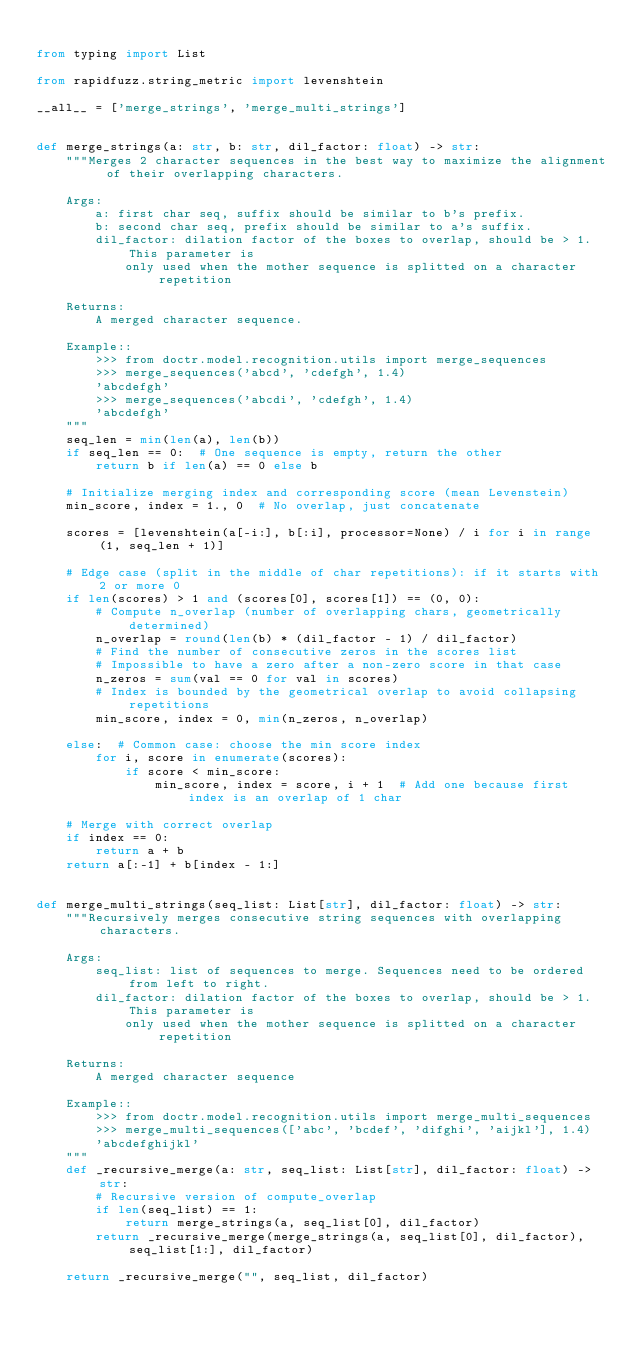<code> <loc_0><loc_0><loc_500><loc_500><_Python_>
from typing import List

from rapidfuzz.string_metric import levenshtein

__all__ = ['merge_strings', 'merge_multi_strings']


def merge_strings(a: str, b: str, dil_factor: float) -> str:
    """Merges 2 character sequences in the best way to maximize the alignment of their overlapping characters.

    Args:
        a: first char seq, suffix should be similar to b's prefix.
        b: second char seq, prefix should be similar to a's suffix.
        dil_factor: dilation factor of the boxes to overlap, should be > 1. This parameter is
            only used when the mother sequence is splitted on a character repetition

    Returns:
        A merged character sequence.

    Example::
        >>> from doctr.model.recognition.utils import merge_sequences
        >>> merge_sequences('abcd', 'cdefgh', 1.4)
        'abcdefgh'
        >>> merge_sequences('abcdi', 'cdefgh', 1.4)
        'abcdefgh'
    """
    seq_len = min(len(a), len(b))
    if seq_len == 0:  # One sequence is empty, return the other
        return b if len(a) == 0 else b

    # Initialize merging index and corresponding score (mean Levenstein)
    min_score, index = 1., 0  # No overlap, just concatenate

    scores = [levenshtein(a[-i:], b[:i], processor=None) / i for i in range(1, seq_len + 1)]

    # Edge case (split in the middle of char repetitions): if it starts with 2 or more 0
    if len(scores) > 1 and (scores[0], scores[1]) == (0, 0):
        # Compute n_overlap (number of overlapping chars, geometrically determined)
        n_overlap = round(len(b) * (dil_factor - 1) / dil_factor)
        # Find the number of consecutive zeros in the scores list
        # Impossible to have a zero after a non-zero score in that case
        n_zeros = sum(val == 0 for val in scores)
        # Index is bounded by the geometrical overlap to avoid collapsing repetitions
        min_score, index = 0, min(n_zeros, n_overlap)

    else:  # Common case: choose the min score index
        for i, score in enumerate(scores):
            if score < min_score:
                min_score, index = score, i + 1  # Add one because first index is an overlap of 1 char

    # Merge with correct overlap
    if index == 0:
        return a + b
    return a[:-1] + b[index - 1:]


def merge_multi_strings(seq_list: List[str], dil_factor: float) -> str:
    """Recursively merges consecutive string sequences with overlapping characters.

    Args:
        seq_list: list of sequences to merge. Sequences need to be ordered from left to right.
        dil_factor: dilation factor of the boxes to overlap, should be > 1. This parameter is
            only used when the mother sequence is splitted on a character repetition

    Returns:
        A merged character sequence

    Example::
        >>> from doctr.model.recognition.utils import merge_multi_sequences
        >>> merge_multi_sequences(['abc', 'bcdef', 'difghi', 'aijkl'], 1.4)
        'abcdefghijkl'
    """
    def _recursive_merge(a: str, seq_list: List[str], dil_factor: float) -> str:
        # Recursive version of compute_overlap
        if len(seq_list) == 1:
            return merge_strings(a, seq_list[0], dil_factor)
        return _recursive_merge(merge_strings(a, seq_list[0], dil_factor), seq_list[1:], dil_factor)

    return _recursive_merge("", seq_list, dil_factor)
</code> 